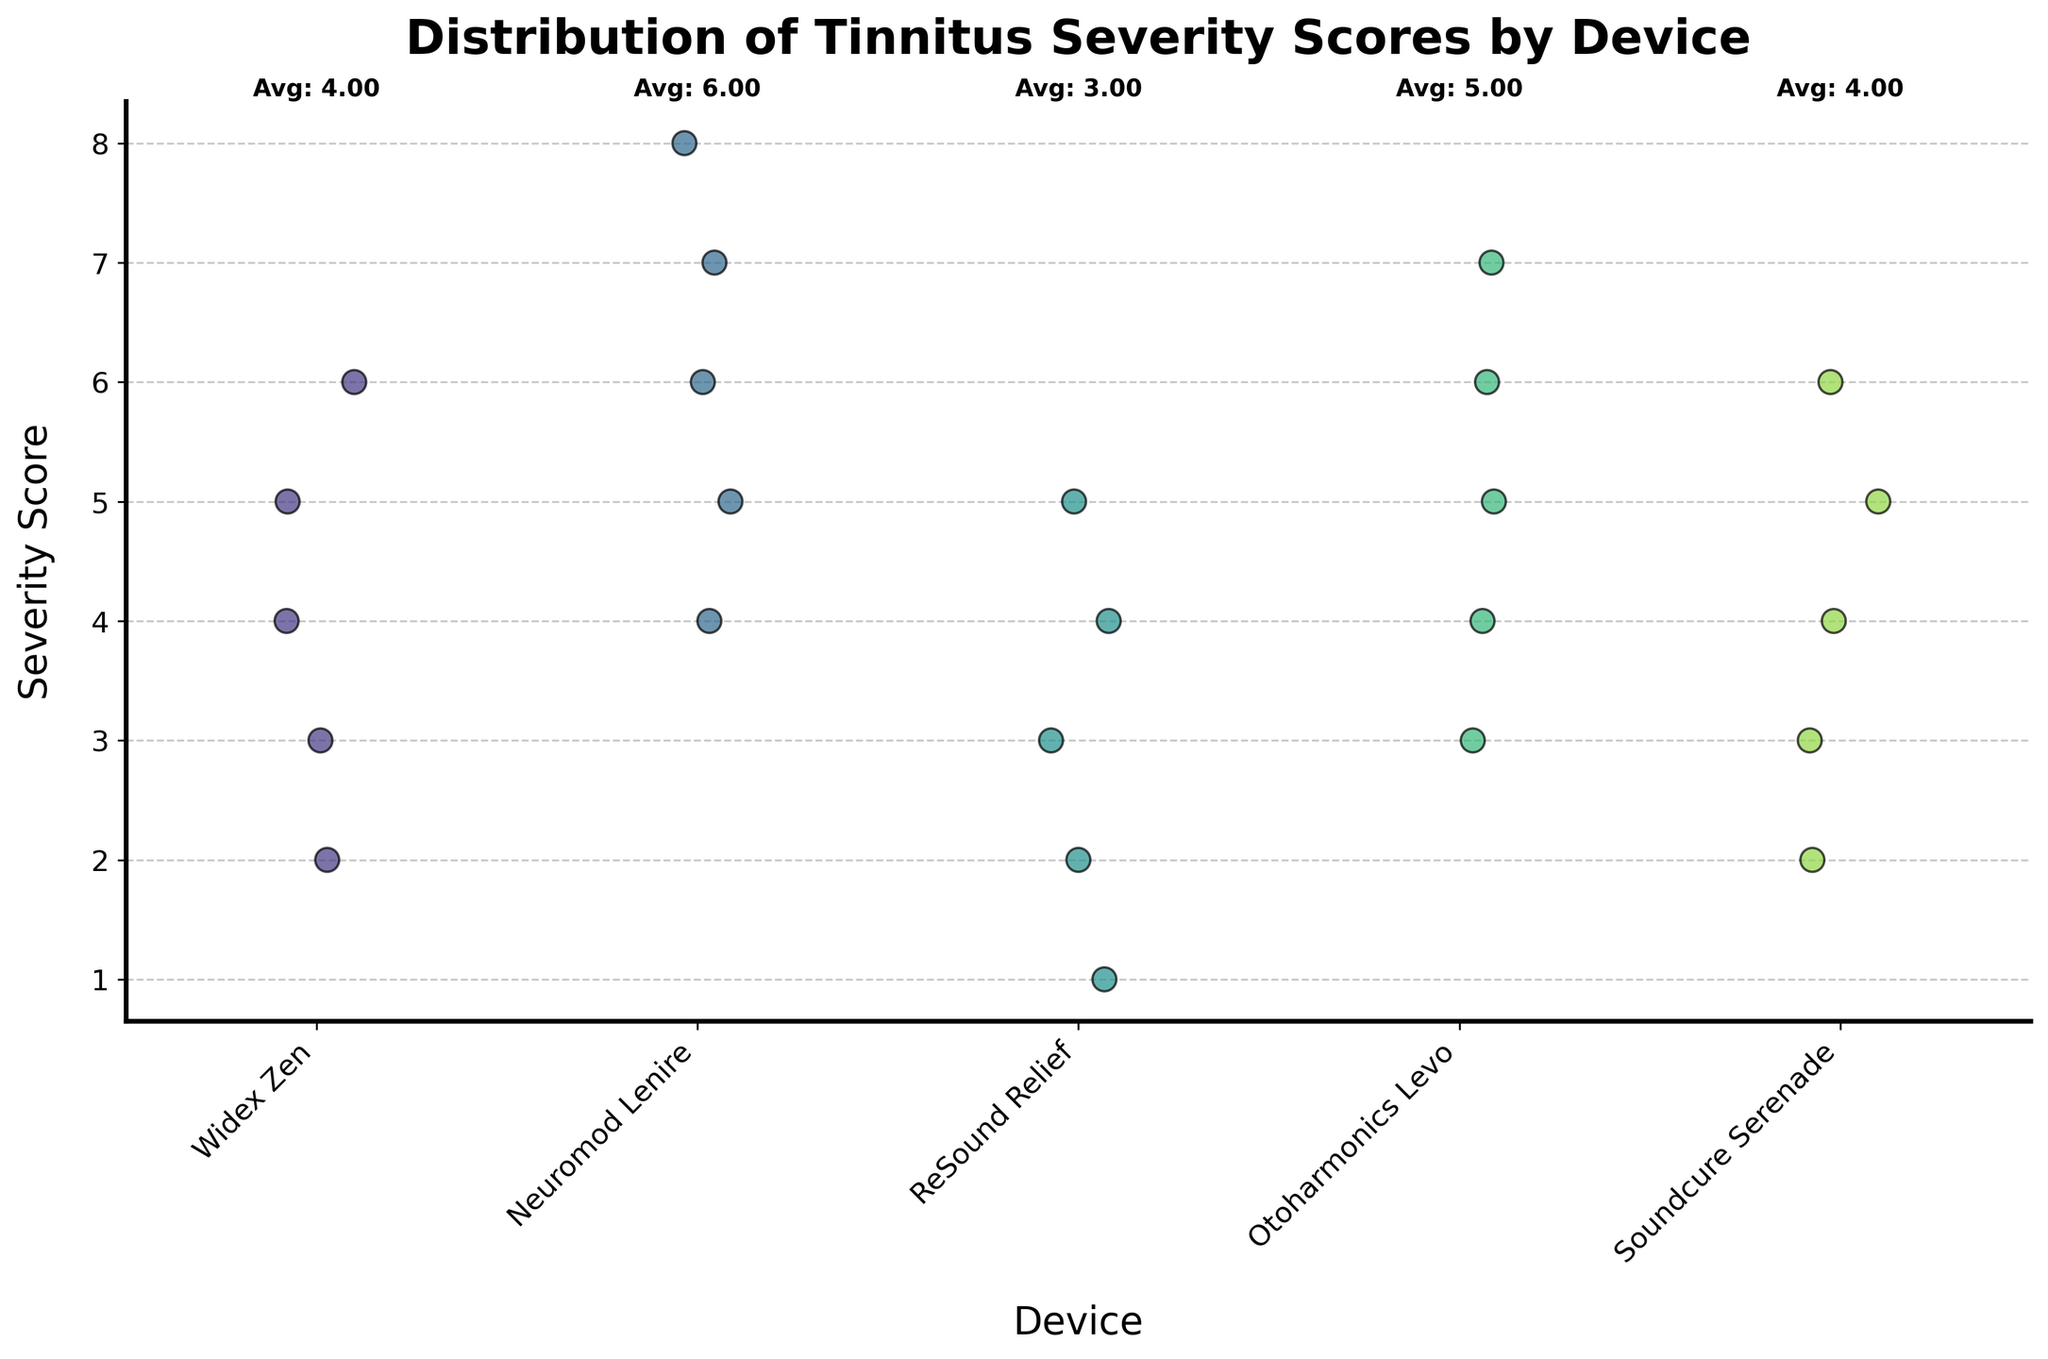What is the title of the figure? The title is typically located at the top of the figure, often in larger or bold font to stand out. In this case, it clearly states, "Distribution of Tinnitus Severity Scores by Device."
Answer: Distribution of Tinnitus Severity Scores by Device Which device has the highest average severity score? To find the device with the highest average severity score, look for the label on the x-axis with the highest average score annotation above it. In this case, the device "Neuromod Lenire" has the annotation "Avg: 6.00" written above it.
Answer: Neuromod Lenire How many devices are compared in this figure? The number of devices can be counted by observing the unique labels on the x-axis. There are five distinct labels: Widex Zen, Neuromod Lenire, ReSound Relief, Otoharmonics Levo, and Soundcure Serenade.
Answer: Five What is the average severity score for Otoharmonics Levo? The average severity score is annotated above each device group. For Otoharmonics Levo, the annotation above it states "Avg: 5.00."
Answer: 5.00 How does the severity score of Soundcure Serenade compare to ReSound Relief and Widex Zen? By comparing the average severity scores written above the device groups: Soundcure Serenade has "Avg: 4.00," ReSound Relief has "Avg: 3.00," and Widex Zen has "Avg: 4.00." Both Soundcure Serenade and Widex Zen have the same average score, and ReSound Relief has a lower average score.
Answer: Soundcure Serenade and Widex Zen are tied, both higher than ReSound Relief Which device shows the greatest spread in severity scores? To determine the greatest spread, observe the range of values (jitter) along the y-axis for each device. Neuromod Lenire shows scores from 4 to 8, making it the widest distribution among the devices displayed.
Answer: Neuromod Lenire Is there any device with a lowest severity score of 1? Examine the y-axis positions of the data points for each device. ReSound Relief has a point at the lowest position, marked as 1.
Answer: ReSound Relief What is the common range of severity scores for Widex Zen? By viewing the y-axis positions of the data points for Widex Zen, the scores range from 2 to 6.
Answer: 2 to 6 